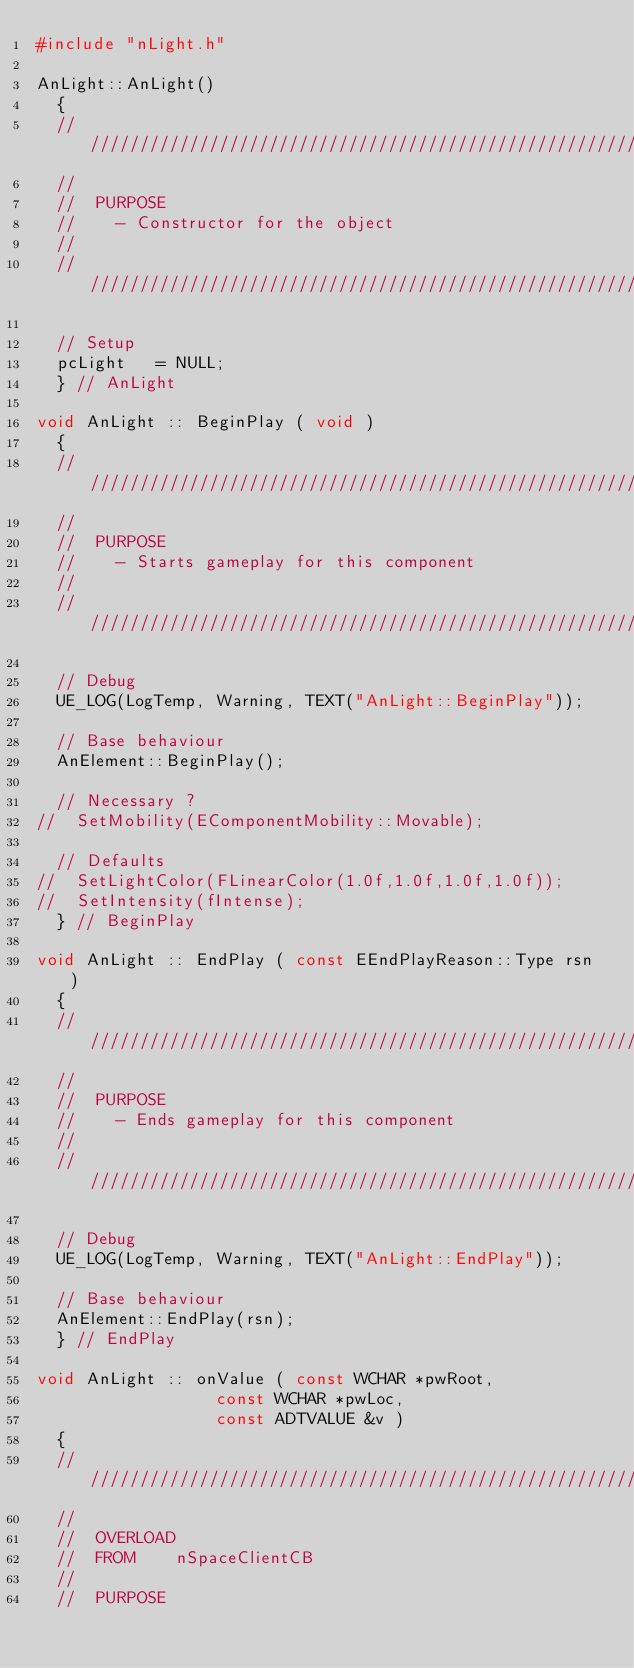<code> <loc_0><loc_0><loc_500><loc_500><_C++_>#include "nLight.h"

AnLight::AnLight()
	{
	////////////////////////////////////////////////////////////////////////
	//
	//	PURPOSE
	//		-	Constructor for the object
	//
	////////////////////////////////////////////////////////////////////////

	// Setup
	pcLight		= NULL;
	}	// AnLight

void AnLight :: BeginPlay ( void )
	{
	////////////////////////////////////////////////////////////////////////
	//
	//	PURPOSE
	//		-	Starts gameplay for this component
	//
	////////////////////////////////////////////////////////////////////////

	// Debug
	UE_LOG(LogTemp, Warning, TEXT("AnLight::BeginPlay"));

	// Base behaviour
	AnElement::BeginPlay();

	// Necessary ?
//	SetMobility(EComponentMobility::Movable);

	// Defaults
//	SetLightColor(FLinearColor(1.0f,1.0f,1.0f,1.0f));
//	SetIntensity(fIntense);
	}	// BeginPlay

void AnLight :: EndPlay ( const EEndPlayReason::Type rsn )
	{
	////////////////////////////////////////////////////////////////////////
	//
	//	PURPOSE
	//		-	Ends gameplay for this component
	//
	////////////////////////////////////////////////////////////////////////

	// Debug
	UE_LOG(LogTemp, Warning, TEXT("AnLight::EndPlay"));

	// Base behaviour
	AnElement::EndPlay(rsn);
	}	// EndPlay

void AnLight :: onValue (	const WCHAR *pwRoot, 
									const WCHAR *pwLoc,
									const ADTVALUE &v )
	{
	////////////////////////////////////////////////////////////////////////
	//
	//	OVERLOAD
	//	FROM		nSpaceClientCB
	//
	//	PURPOSE</code> 